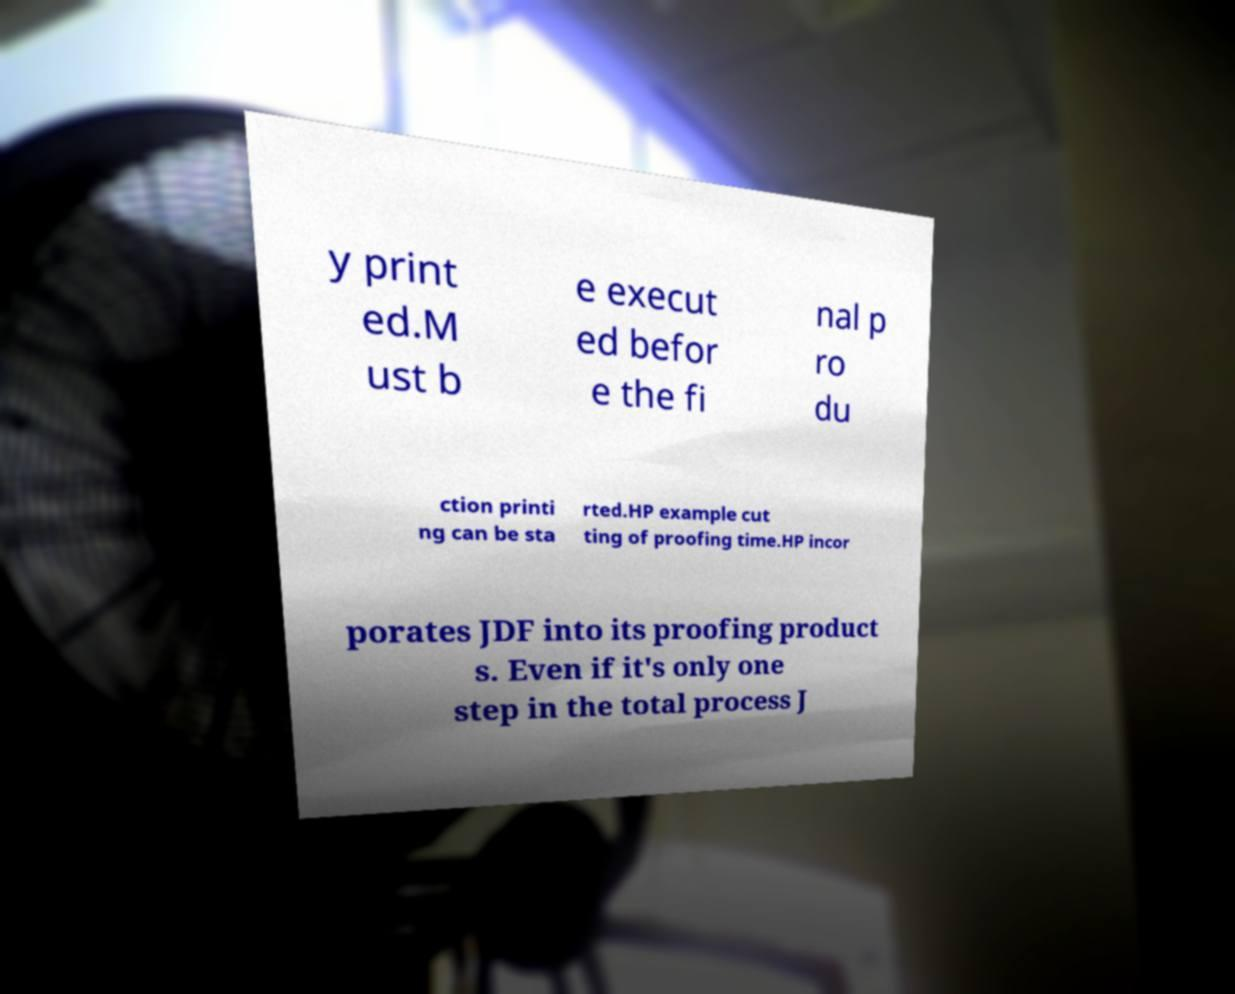Could you extract and type out the text from this image? y print ed.M ust b e execut ed befor e the fi nal p ro du ction printi ng can be sta rted.HP example cut ting of proofing time.HP incor porates JDF into its proofing product s. Even if it's only one step in the total process J 